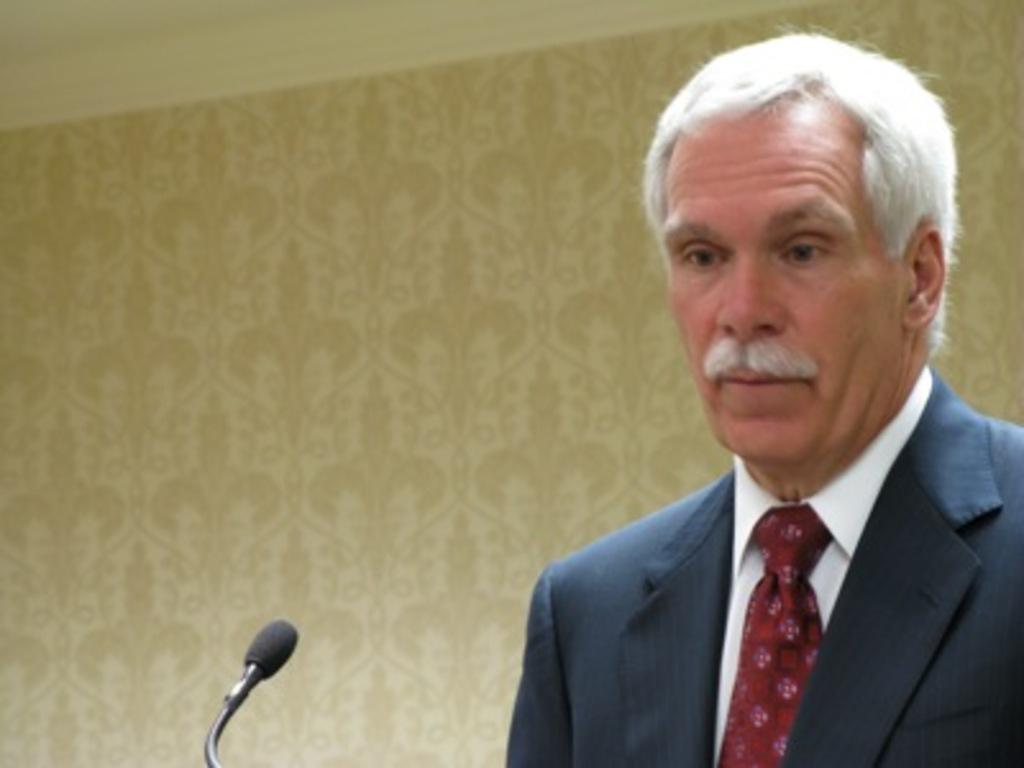What is located on the right side of the image? There is a person on the right side of the image. What is the person holding in the image? The person appears to be holding a microphone. What might the person be doing with the microphone? The person may be talking, as they are holding a microphone. What can be seen in the background of the image? There is a wall in the background of the image. What is the aftermath of the magic show in the image? There is no magic show or aftermath present in the image; it features a person holding a microphone. How many fans are visible in the image? There are no fans visible in the image. 